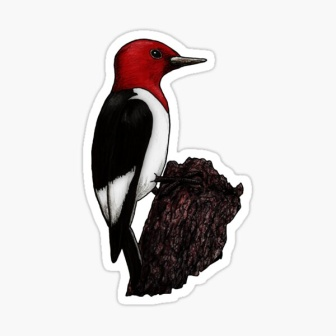Imagine this bird interacts with a human in the forest. Describe the scenario realistically. As Maya, an avid bird watcher, quietly made her way through the forest, she spotted a flash of vibrant red. Slowly, she raised her binoculars and focused on the source of the color. There, perched on a weathered tree stump, was a red-headed woodpecker. The bird seemed to take little notice of her, preoccupied with its task of searching for insects in the bark. Maya stood still, her breath held so as not to disturb the bird. She watched as it pecked methodically, its movements precise and purposeful. After a few minutes, the woodpecker paused, as if sensing Maya's presence. It turned its head curiously, eyeing her with a mix of caution and curiosity. Maya slowly lowered her binoculars, her eyes locking with the bird's for a brief, magical moment of connection. Realizing she meant no harm, the woodpecker quickly returned to its work. Maya smiled, feeling privileged to have witnessed such a beautiful creature in its natural habitat, and carefully continued her walk, leaving the woodpecker to its peaceful task.  What if the stump the woodpecker is on had a secret? As the red-headed woodpecker tapped away at the tree stump, it accidentally revealed something curious. Beneath the rough bark, slightly concealed, was an ancient engraving—the likes of which no ordinary tree stump should have. Intrigued, the woodpecker pecked more vigorously, unveiling a pattern of intertwining spirals and runes glowing faintly with a cerulean light. The stump was not just a perch but the hidden gate to a lost underground realm that hadn't been discovered for centuries. The woodpecker's pecking activated the stump's magic, causing the ground to tremble slightly. Suddenly, roots began to part, revealing a small opening just large enough for the woodpecker to slip through. Driven by an unexplainable impulse, the bird ventured into the opening, descending into a mysterious subterranean world filled with treasures and artifacts from an ancient civilization. The air was filled with the scent of ancient wood and the whisper of forgotten secrets. This was a world where nature and magic converged, a place where the woodpecker would soon discover a destiny far greater than just pecking at trees—a destiny as the guardian of an ancient legacy. 